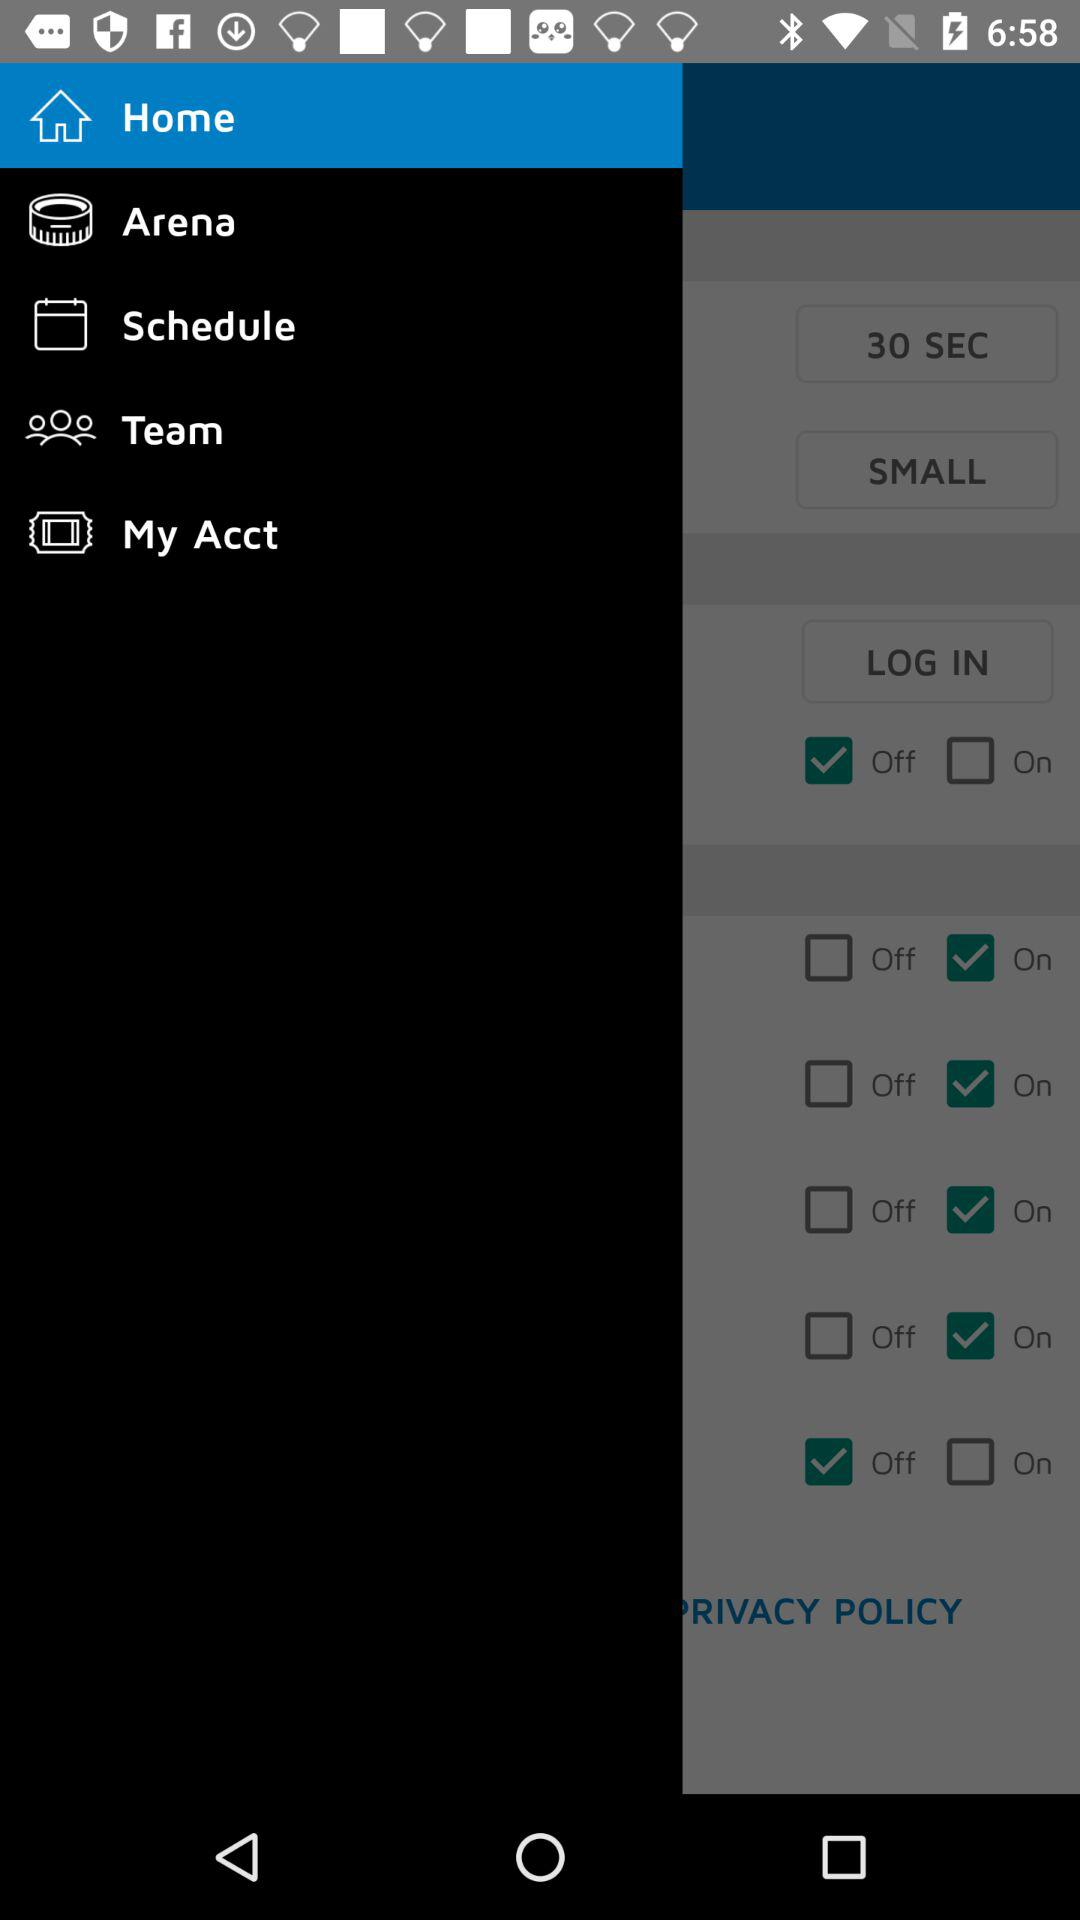What is the time duration? The time duration is 30 seconds. 